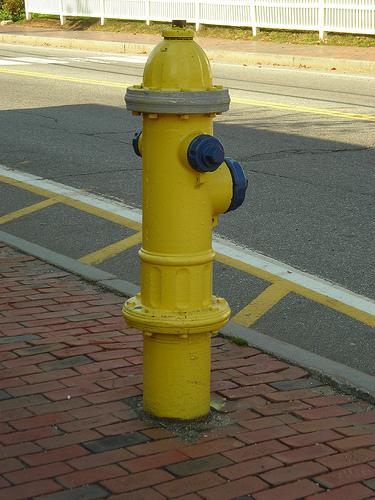Describe two elements of the scene related to traffic regulations in the image. Yellow no parking lines are present on the street, and there are white pedestrian crossing lines. What color and type of boundary can be seen in the distance in the image? In the distance, there is a white picket fence. Report the primary material of the sidewalk on the opposite side of the street in the image. On the opposite side of the street, the sidewalk is made of red bricks. Identify the primary object in the image and its color. The primary object in the image is a yellow fire hydrant with blue caps. Based on the image, describe the general ambiance of the location. The location has an urban setting with an empty street, sidewalks, and a yellow fire hydrant, conveying a functional, everyday mood. Examine the image and depict the border of the road. There's a concrete curb along the road, and a white wooden fence next to the road. What type of surface is the fire hydrant resting on in the image? The fire hydrant is resting on a weathered cobblestone sidewalk. Analyze the image and provide a brief overview of the scene, including three key elements. The scene features an empty asphalt street surrounded by a weathered cobblestone sidewalk, a yellow fire hydrant with blue caps, and white pedestrian crossing lines. Mention two key attributes of the fire hydrant in the image. The fire hydrant is yellow and has blue nozzles. In the image, comment on the condition of the roads. The roads are in poor condition with cracks in the paved road and eroded base of the fire hydrant. Notice the large graffiti art on the side of the building casting the shadow on the ground, it adds character to the street! There is no mention of graffiti or a building with graffiti art in the image. This instruction is misleading because it suggests the existence of an artistic element that isn't present in the image. Can you find the dog lying down on the brick sidewalk, right by the white picket fence? It appears so relaxed! No, it's not mentioned in the image. Can you spot the purple bicycle leaning against the white fence? It's such a unique color! There is no mention of a bicycle in the image, let alone a purple one. The instruction is misleading since it fabricates an object that doesn't exist in the image. Please observe the vintage gas lamp standing beside the fire hydrant, isn't it reminiscent of old times?  There is no mention of a gas lamp or any other type of vintage object in the image. This instruction falsely introduces a historical context that is not present in the image. 